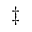<formula> <loc_0><loc_0><loc_500><loc_500>\ddagger</formula> 